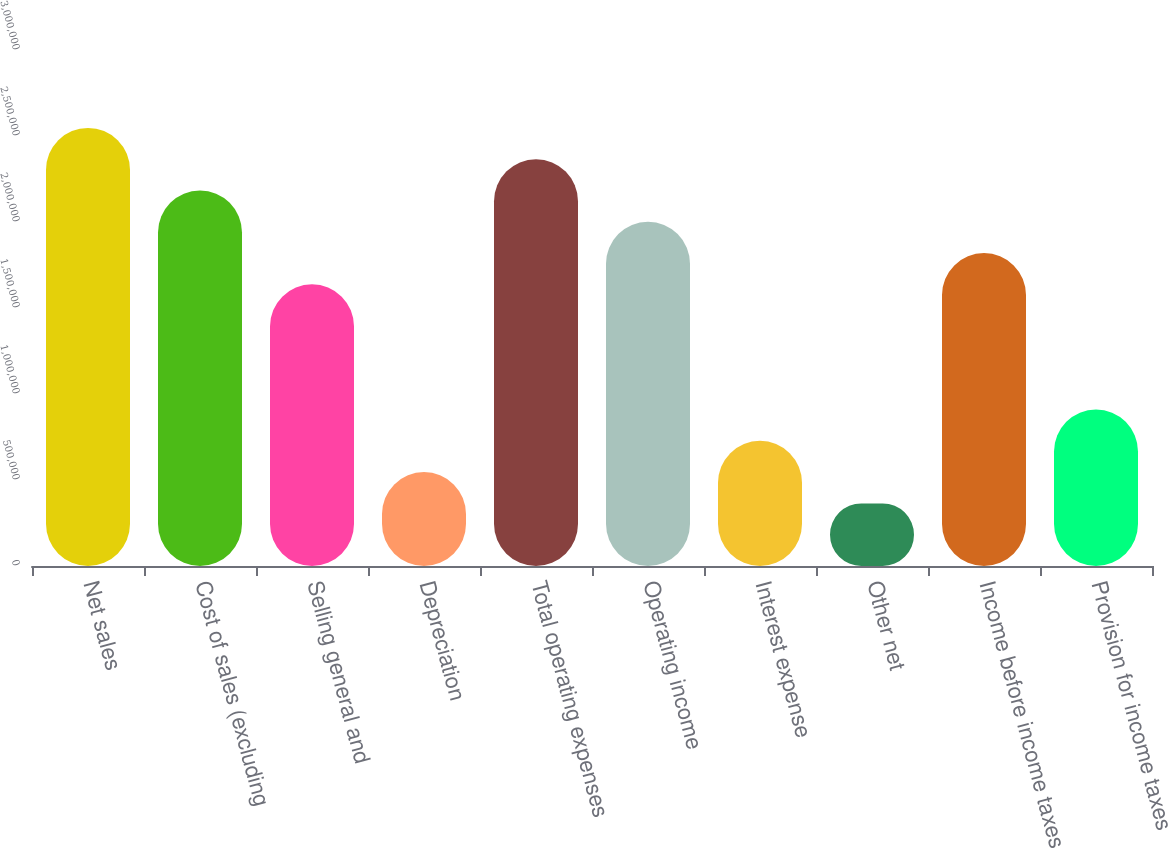Convert chart to OTSL. <chart><loc_0><loc_0><loc_500><loc_500><bar_chart><fcel>Net sales<fcel>Cost of sales (excluding<fcel>Selling general and<fcel>Depreciation<fcel>Total operating expenses<fcel>Operating income<fcel>Interest expense<fcel>Other net<fcel>Income before income taxes<fcel>Provision for income taxes<nl><fcel>2.54701e+06<fcel>2.18315e+06<fcel>1.63736e+06<fcel>545788<fcel>2.36508e+06<fcel>2.00122e+06<fcel>727717<fcel>363859<fcel>1.81929e+06<fcel>909646<nl></chart> 